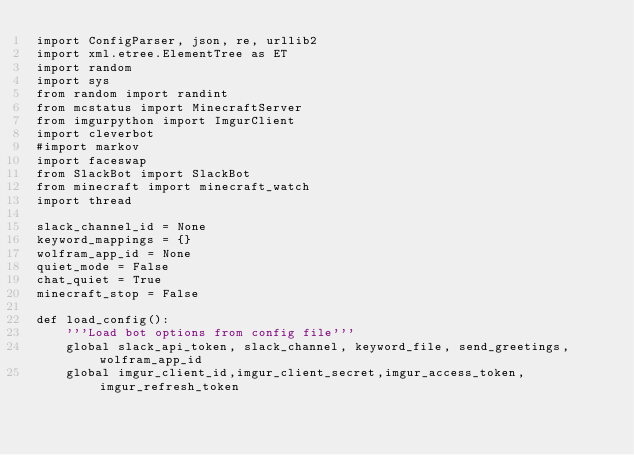<code> <loc_0><loc_0><loc_500><loc_500><_Python_>import ConfigParser, json, re, urllib2
import xml.etree.ElementTree as ET
import random
import sys
from random import randint
from mcstatus import MinecraftServer
from imgurpython import ImgurClient
import cleverbot
#import markov
import faceswap
from SlackBot import SlackBot
from minecraft import minecraft_watch
import thread

slack_channel_id = None
keyword_mappings = {}
wolfram_app_id = None
quiet_mode = False
chat_quiet = True
minecraft_stop = False

def load_config():
    '''Load bot options from config file'''
    global slack_api_token, slack_channel, keyword_file, send_greetings, wolfram_app_id
    global imgur_client_id,imgur_client_secret,imgur_access_token,imgur_refresh_token</code> 